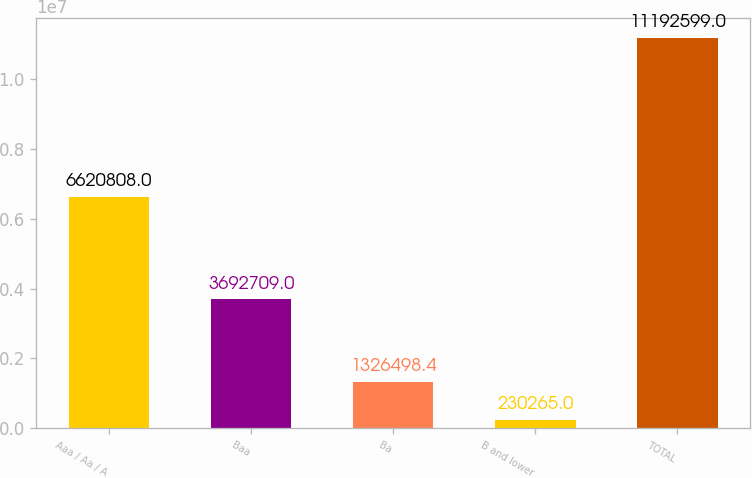Convert chart. <chart><loc_0><loc_0><loc_500><loc_500><bar_chart><fcel>Aaa / Aa / A<fcel>Baa<fcel>Ba<fcel>B and lower<fcel>TOTAL<nl><fcel>6.62081e+06<fcel>3.69271e+06<fcel>1.3265e+06<fcel>230265<fcel>1.11926e+07<nl></chart> 